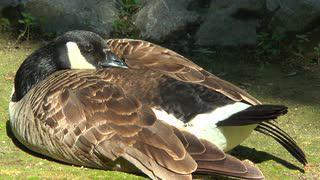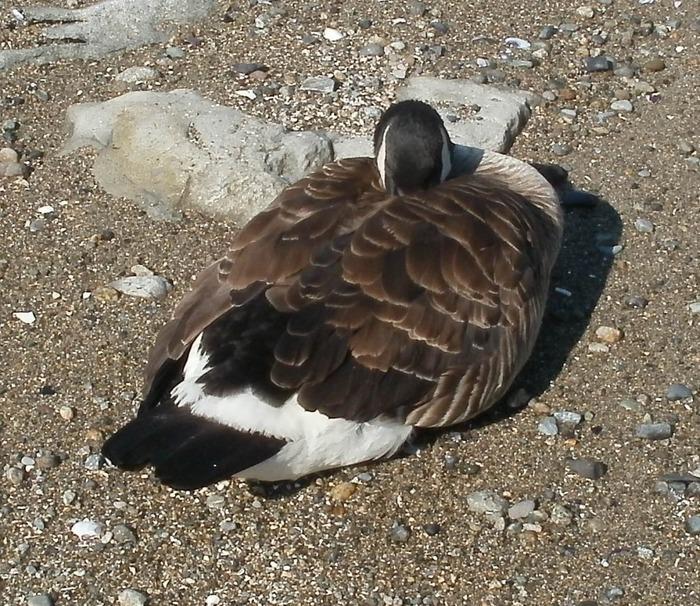The first image is the image on the left, the second image is the image on the right. Given the left and right images, does the statement "There are two birds in total." hold true? Answer yes or no. Yes. The first image is the image on the left, the second image is the image on the right. For the images displayed, is the sentence "A single bird has its head in its feathers." factually correct? Answer yes or no. Yes. 